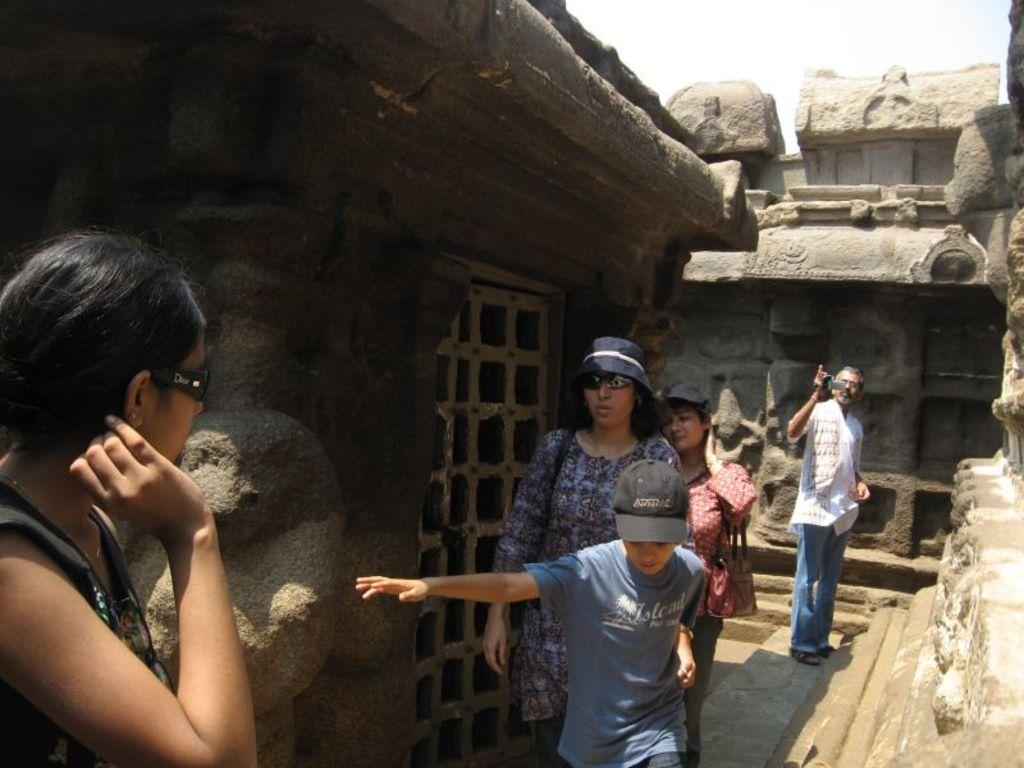What is the main subject of the image? There are people in the center of the image. What can be seen in the background of the image? There is a fort in the background of the image. What is visible at the top of the image? The sky is visible at the top of the image. What type of yard is visible in the image? There is no yard present in the image. 